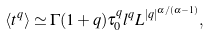<formula> <loc_0><loc_0><loc_500><loc_500>\langle t ^ { q } \rangle \simeq \Gamma ( 1 + q ) \tau _ { 0 } ^ { q } l ^ { q } L ^ { | q | ^ { \alpha / ( \alpha - 1 ) } } ,</formula> 